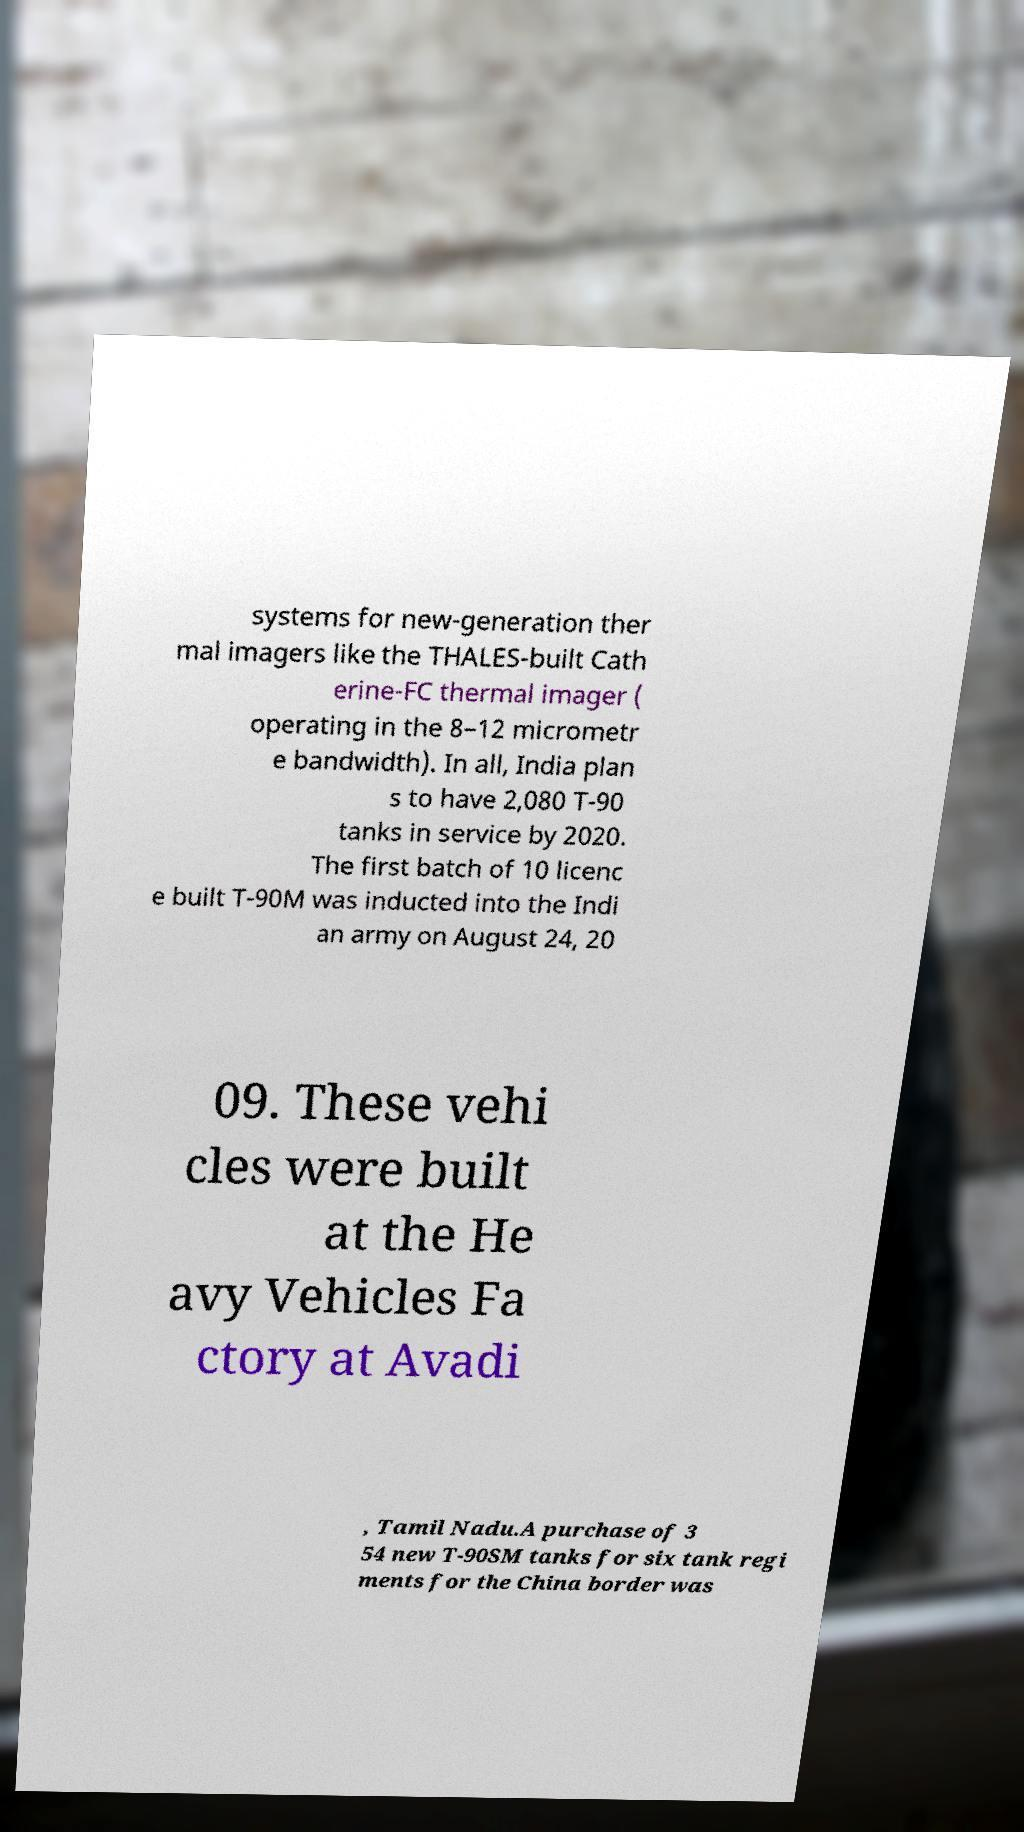Could you extract and type out the text from this image? systems for new-generation ther mal imagers like the THALES-built Cath erine-FC thermal imager ( operating in the 8–12 micrometr e bandwidth). In all, India plan s to have 2,080 T-90 tanks in service by 2020. The first batch of 10 licenc e built T-90M was inducted into the Indi an army on August 24, 20 09. These vehi cles were built at the He avy Vehicles Fa ctory at Avadi , Tamil Nadu.A purchase of 3 54 new T-90SM tanks for six tank regi ments for the China border was 